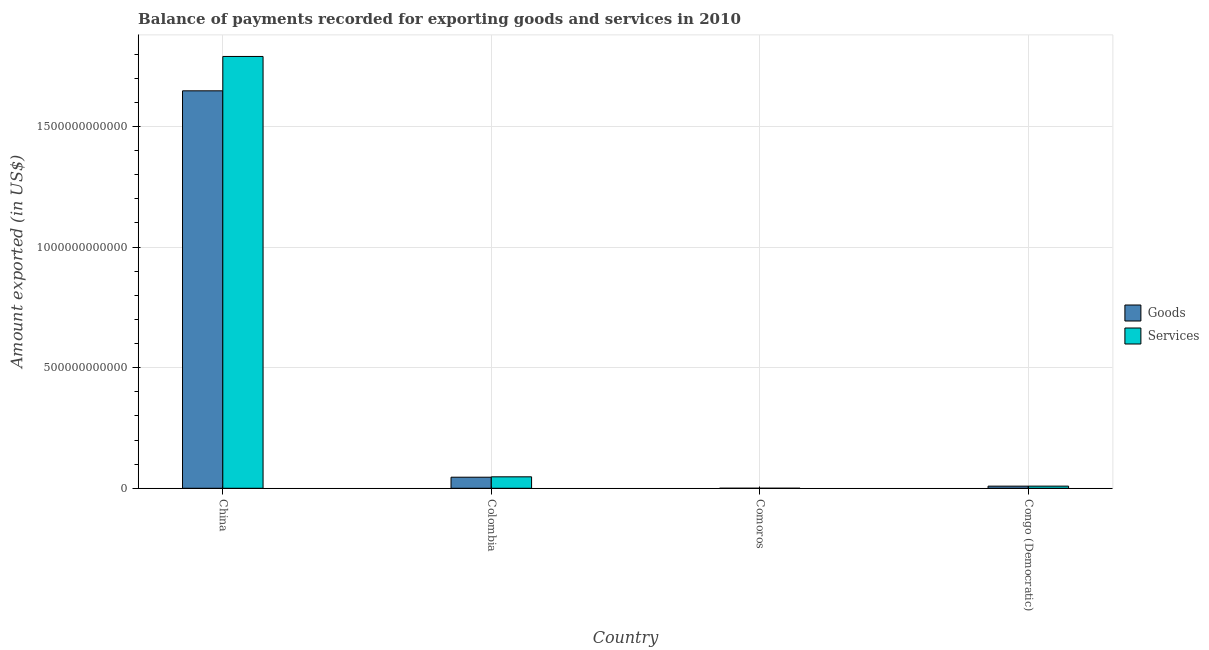How many groups of bars are there?
Your response must be concise. 4. Are the number of bars per tick equal to the number of legend labels?
Offer a terse response. Yes. How many bars are there on the 3rd tick from the left?
Offer a very short reply. 2. What is the amount of services exported in Comoros?
Provide a short and direct response. 9.07e+07. Across all countries, what is the maximum amount of goods exported?
Keep it short and to the point. 1.65e+12. Across all countries, what is the minimum amount of goods exported?
Offer a very short reply. 8.74e+07. In which country was the amount of goods exported maximum?
Give a very brief answer. China. In which country was the amount of services exported minimum?
Ensure brevity in your answer.  Comoros. What is the total amount of goods exported in the graph?
Your answer should be compact. 1.70e+12. What is the difference between the amount of services exported in China and that in Comoros?
Provide a succinct answer. 1.79e+12. What is the difference between the amount of services exported in China and the amount of goods exported in Congo (Democratic)?
Give a very brief answer. 1.78e+12. What is the average amount of goods exported per country?
Your answer should be very brief. 4.26e+11. What is the difference between the amount of services exported and amount of goods exported in Colombia?
Offer a terse response. 1.67e+09. In how many countries, is the amount of services exported greater than 600000000000 US$?
Provide a succinct answer. 1. What is the ratio of the amount of goods exported in Colombia to that in Congo (Democratic)?
Your response must be concise. 5.17. What is the difference between the highest and the second highest amount of services exported?
Your answer should be compact. 1.74e+12. What is the difference between the highest and the lowest amount of goods exported?
Ensure brevity in your answer.  1.65e+12. What does the 1st bar from the left in Congo (Democratic) represents?
Your answer should be compact. Goods. What does the 2nd bar from the right in Colombia represents?
Keep it short and to the point. Goods. How many bars are there?
Your answer should be compact. 8. Are all the bars in the graph horizontal?
Provide a short and direct response. No. What is the difference between two consecutive major ticks on the Y-axis?
Your answer should be very brief. 5.00e+11. Are the values on the major ticks of Y-axis written in scientific E-notation?
Ensure brevity in your answer.  No. How many legend labels are there?
Provide a short and direct response. 2. How are the legend labels stacked?
Your answer should be very brief. Vertical. What is the title of the graph?
Make the answer very short. Balance of payments recorded for exporting goods and services in 2010. What is the label or title of the Y-axis?
Offer a terse response. Amount exported (in US$). What is the Amount exported (in US$) of Goods in China?
Make the answer very short. 1.65e+12. What is the Amount exported (in US$) in Services in China?
Offer a very short reply. 1.79e+12. What is the Amount exported (in US$) in Goods in Colombia?
Provide a succinct answer. 4.59e+1. What is the Amount exported (in US$) of Services in Colombia?
Ensure brevity in your answer.  4.75e+1. What is the Amount exported (in US$) in Goods in Comoros?
Ensure brevity in your answer.  8.74e+07. What is the Amount exported (in US$) of Services in Comoros?
Keep it short and to the point. 9.07e+07. What is the Amount exported (in US$) in Goods in Congo (Democratic)?
Your answer should be compact. 8.87e+09. What is the Amount exported (in US$) of Services in Congo (Democratic)?
Provide a succinct answer. 8.91e+09. Across all countries, what is the maximum Amount exported (in US$) in Goods?
Ensure brevity in your answer.  1.65e+12. Across all countries, what is the maximum Amount exported (in US$) in Services?
Provide a succinct answer. 1.79e+12. Across all countries, what is the minimum Amount exported (in US$) of Goods?
Offer a very short reply. 8.74e+07. Across all countries, what is the minimum Amount exported (in US$) of Services?
Provide a succinct answer. 9.07e+07. What is the total Amount exported (in US$) of Goods in the graph?
Keep it short and to the point. 1.70e+12. What is the total Amount exported (in US$) in Services in the graph?
Ensure brevity in your answer.  1.85e+12. What is the difference between the Amount exported (in US$) of Goods in China and that in Colombia?
Your response must be concise. 1.60e+12. What is the difference between the Amount exported (in US$) in Services in China and that in Colombia?
Keep it short and to the point. 1.74e+12. What is the difference between the Amount exported (in US$) of Goods in China and that in Comoros?
Your answer should be very brief. 1.65e+12. What is the difference between the Amount exported (in US$) in Services in China and that in Comoros?
Your answer should be compact. 1.79e+12. What is the difference between the Amount exported (in US$) in Goods in China and that in Congo (Democratic)?
Keep it short and to the point. 1.64e+12. What is the difference between the Amount exported (in US$) of Services in China and that in Congo (Democratic)?
Ensure brevity in your answer.  1.78e+12. What is the difference between the Amount exported (in US$) of Goods in Colombia and that in Comoros?
Provide a succinct answer. 4.58e+1. What is the difference between the Amount exported (in US$) of Services in Colombia and that in Comoros?
Your response must be concise. 4.75e+1. What is the difference between the Amount exported (in US$) of Goods in Colombia and that in Congo (Democratic)?
Give a very brief answer. 3.70e+1. What is the difference between the Amount exported (in US$) in Services in Colombia and that in Congo (Democratic)?
Give a very brief answer. 3.86e+1. What is the difference between the Amount exported (in US$) in Goods in Comoros and that in Congo (Democratic)?
Provide a short and direct response. -8.78e+09. What is the difference between the Amount exported (in US$) of Services in Comoros and that in Congo (Democratic)?
Keep it short and to the point. -8.82e+09. What is the difference between the Amount exported (in US$) in Goods in China and the Amount exported (in US$) in Services in Colombia?
Provide a short and direct response. 1.60e+12. What is the difference between the Amount exported (in US$) in Goods in China and the Amount exported (in US$) in Services in Comoros?
Give a very brief answer. 1.65e+12. What is the difference between the Amount exported (in US$) in Goods in China and the Amount exported (in US$) in Services in Congo (Democratic)?
Make the answer very short. 1.64e+12. What is the difference between the Amount exported (in US$) in Goods in Colombia and the Amount exported (in US$) in Services in Comoros?
Provide a short and direct response. 4.58e+1. What is the difference between the Amount exported (in US$) in Goods in Colombia and the Amount exported (in US$) in Services in Congo (Democratic)?
Provide a succinct answer. 3.70e+1. What is the difference between the Amount exported (in US$) of Goods in Comoros and the Amount exported (in US$) of Services in Congo (Democratic)?
Offer a very short reply. -8.83e+09. What is the average Amount exported (in US$) in Goods per country?
Give a very brief answer. 4.26e+11. What is the average Amount exported (in US$) of Services per country?
Offer a very short reply. 4.62e+11. What is the difference between the Amount exported (in US$) of Goods and Amount exported (in US$) of Services in China?
Keep it short and to the point. -1.42e+11. What is the difference between the Amount exported (in US$) in Goods and Amount exported (in US$) in Services in Colombia?
Ensure brevity in your answer.  -1.67e+09. What is the difference between the Amount exported (in US$) in Goods and Amount exported (in US$) in Services in Comoros?
Your answer should be compact. -3.23e+06. What is the difference between the Amount exported (in US$) of Goods and Amount exported (in US$) of Services in Congo (Democratic)?
Give a very brief answer. -4.83e+07. What is the ratio of the Amount exported (in US$) in Goods in China to that in Colombia?
Your response must be concise. 35.92. What is the ratio of the Amount exported (in US$) of Services in China to that in Colombia?
Your answer should be very brief. 37.65. What is the ratio of the Amount exported (in US$) in Goods in China to that in Comoros?
Your response must be concise. 1.88e+04. What is the ratio of the Amount exported (in US$) in Services in China to that in Comoros?
Give a very brief answer. 1.97e+04. What is the ratio of the Amount exported (in US$) of Goods in China to that in Congo (Democratic)?
Your answer should be compact. 185.84. What is the ratio of the Amount exported (in US$) of Services in China to that in Congo (Democratic)?
Give a very brief answer. 200.81. What is the ratio of the Amount exported (in US$) in Goods in Colombia to that in Comoros?
Offer a very short reply. 524.69. What is the ratio of the Amount exported (in US$) of Services in Colombia to that in Comoros?
Your response must be concise. 524.36. What is the ratio of the Amount exported (in US$) of Goods in Colombia to that in Congo (Democratic)?
Your answer should be compact. 5.17. What is the ratio of the Amount exported (in US$) in Services in Colombia to that in Congo (Democratic)?
Provide a short and direct response. 5.33. What is the ratio of the Amount exported (in US$) of Goods in Comoros to that in Congo (Democratic)?
Provide a succinct answer. 0.01. What is the ratio of the Amount exported (in US$) in Services in Comoros to that in Congo (Democratic)?
Your answer should be compact. 0.01. What is the difference between the highest and the second highest Amount exported (in US$) in Goods?
Give a very brief answer. 1.60e+12. What is the difference between the highest and the second highest Amount exported (in US$) in Services?
Provide a short and direct response. 1.74e+12. What is the difference between the highest and the lowest Amount exported (in US$) in Goods?
Your answer should be very brief. 1.65e+12. What is the difference between the highest and the lowest Amount exported (in US$) of Services?
Offer a very short reply. 1.79e+12. 